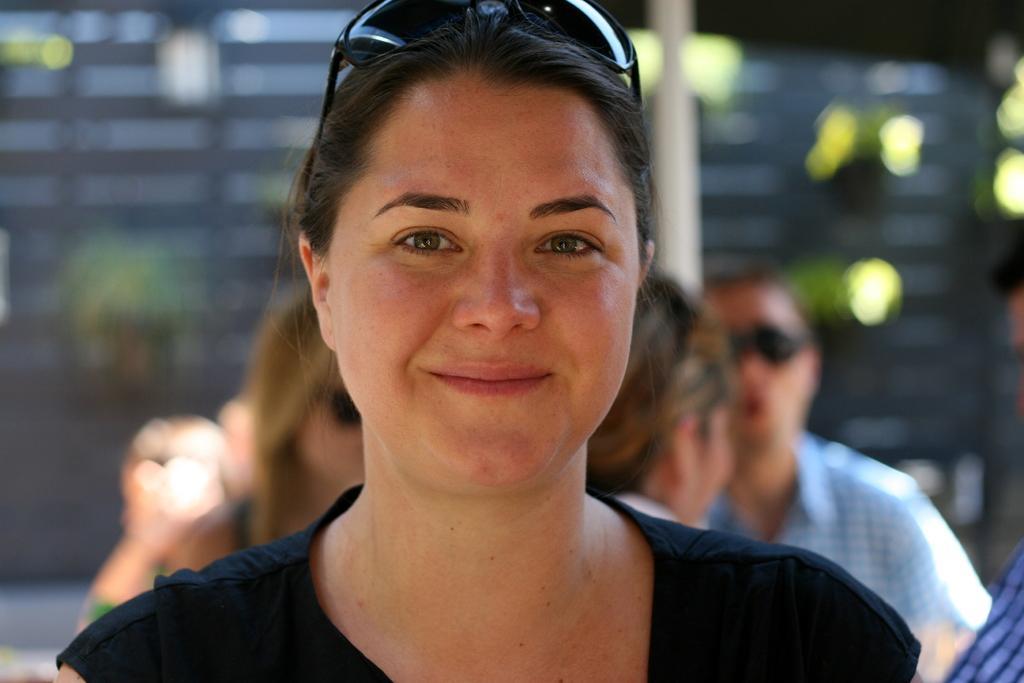Please provide a concise description of this image. In this image in the foreground there is one woman who is smiling, and in the background there are some people who are sitting and also there are flower pots and plants pole and a wall. 